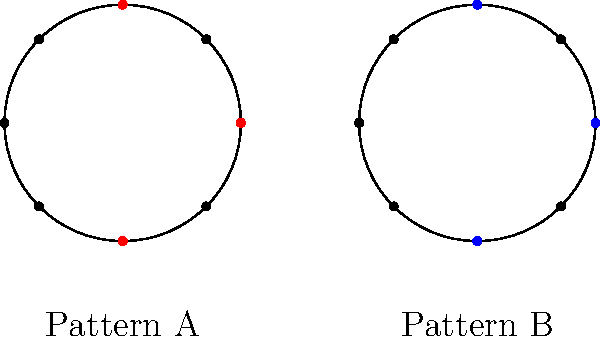Examine the two circular rhythm notations labeled Pattern A and Pattern B. Are these patterns congruent in terms of their rhythmic structure? If so, explain how they are related. To determine if the two circular rhythm patterns are congruent, we need to follow these steps:

1. Analyze the structure of each pattern:
   - Pattern A has three beats marked, forming an isosceles right triangle.
   - Pattern B also has three beats marked, forming an isosceles right triangle.

2. Compare the relative positions of the beats:
   - In Pattern A, the beats are at 0°, 90°, and 270° (or -90°).
   - In Pattern B, the beats are at 0°, 90°, and 270° (or -90°).

3. Check for rotational symmetry:
   - The patterns are identical in their beat placement.
   - No rotation is needed to make them align perfectly.

4. Consider the musical interpretation:
   - Both patterns represent a rhythm with beats on the first count (0°), an offbeat (90°), and a syncopated beat (270°).
   - This creates the same rhythmic feel in both cases.

5. Conclusion:
   - The patterns are congruent because they have the same shape and orientation within their respective circles.
   - They represent identical rhythmic structures, just displaced in space.

In traditional percussion terms, these patterns would produce the same rhythm when played, maintaining the classic structure that a traditionalist would appreciate.
Answer: Yes, congruent 